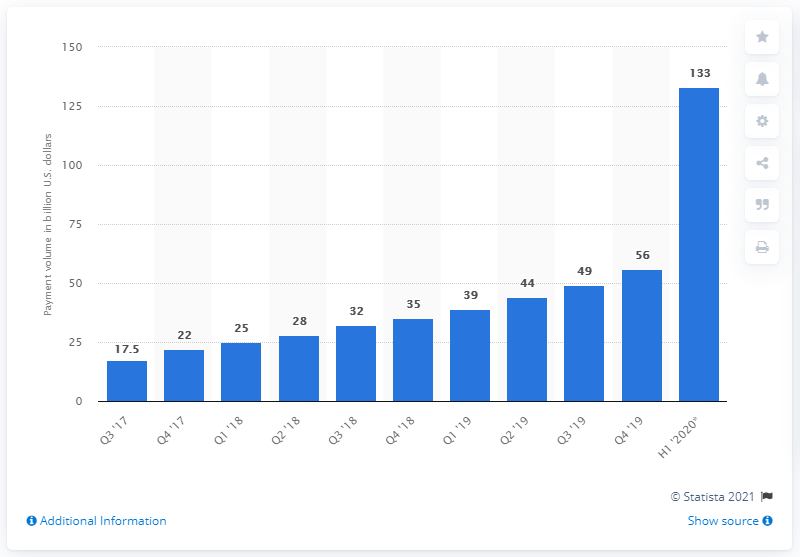Specify some key components in this picture. In the first half of 2020, Zelle moved a total of $133 million across its payment network. The payment volume of Zelle in the fourth quarter of 2020 was 56... 